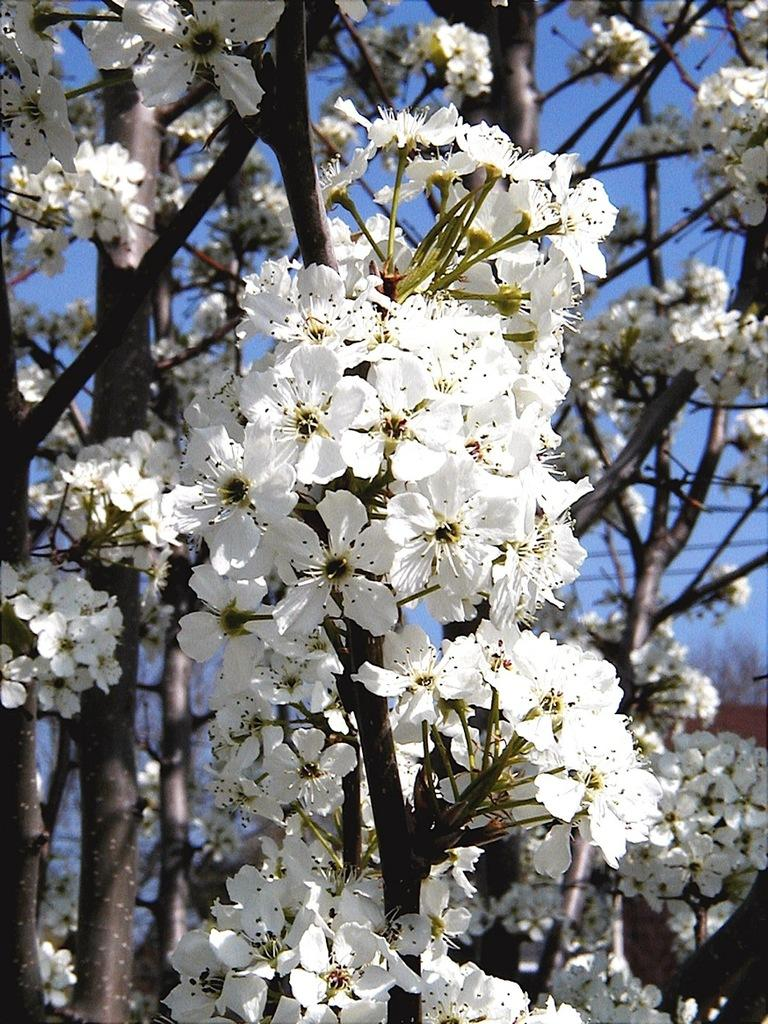What type of flowers can be seen in the foreground of the image? There are white color flowers in the foreground of the image. Where are the flowers located? The flowers are on a tree. What can be seen in the background of the image? The sky is visible in the background of the image. How many bells are hanging from the tree in the image? There are no bells present in the image; it features white color flowers on a tree. Can you spot a ladybug on any of the flowers in the image? There is no ladybug visible on the flowers in the image. 